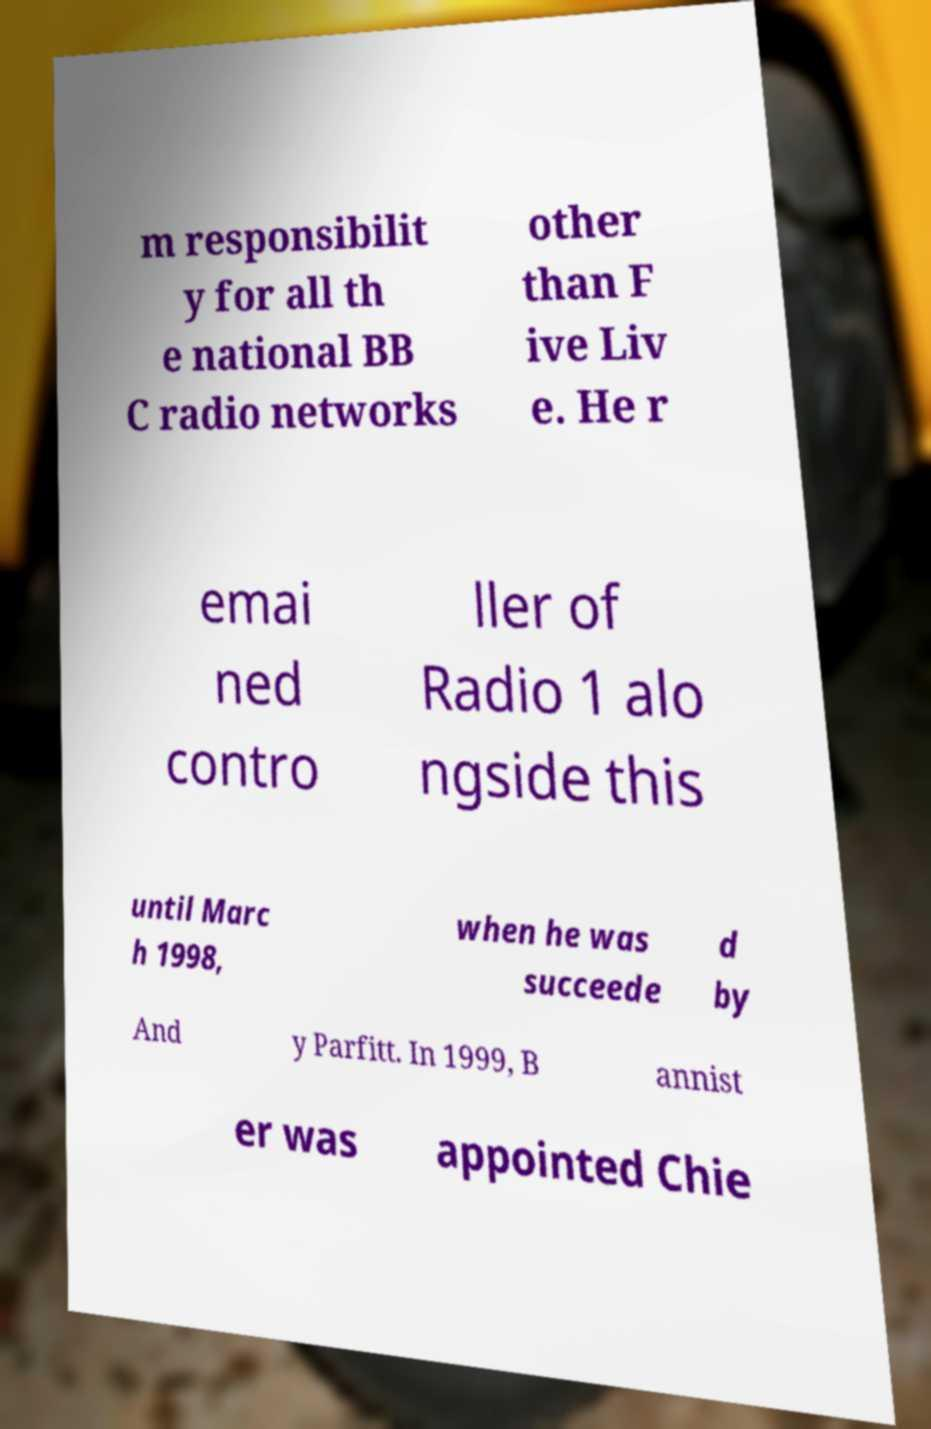For documentation purposes, I need the text within this image transcribed. Could you provide that? m responsibilit y for all th e national BB C radio networks other than F ive Liv e. He r emai ned contro ller of Radio 1 alo ngside this until Marc h 1998, when he was succeede d by And y Parfitt. In 1999, B annist er was appointed Chie 